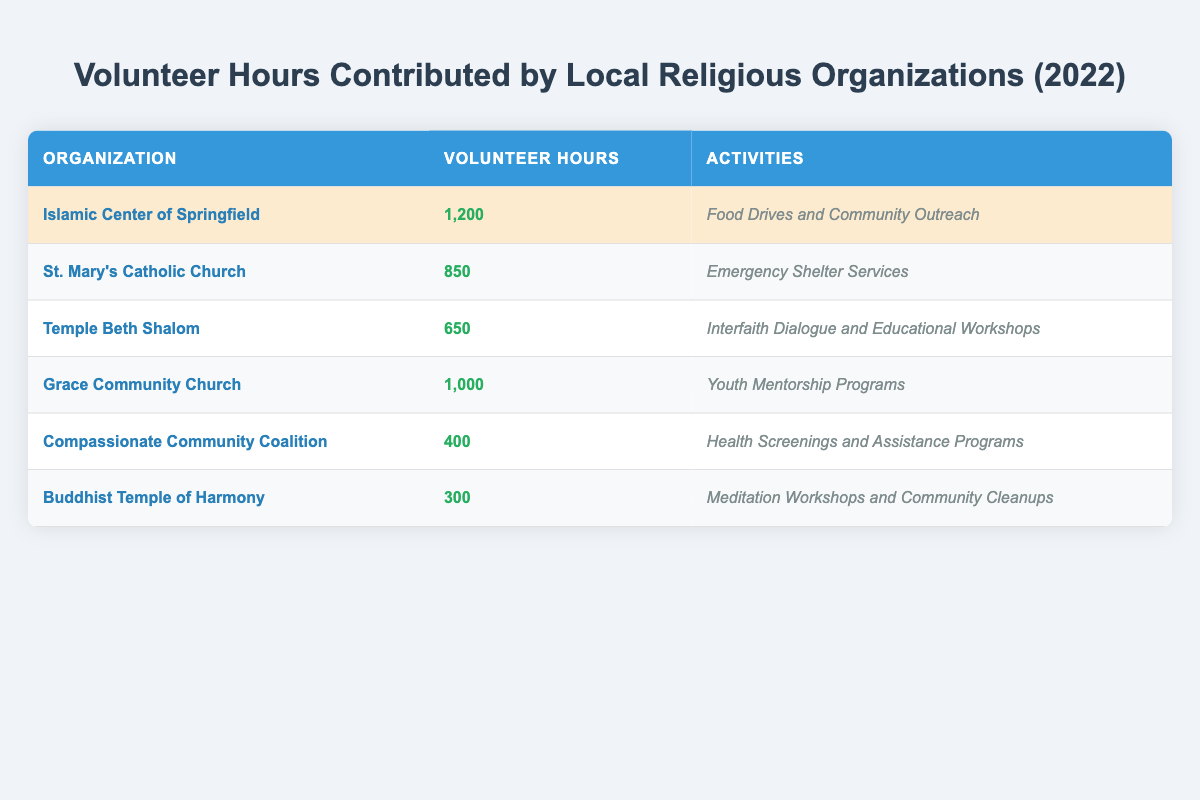What organization contributed the most volunteer hours? The table lists the volunteer hours for each organization, and the Islamic Center of Springfield has the highest number at 1,200 hours.
Answer: Islamic Center of Springfield How many volunteer hours did St. Mary's Catholic Church contribute? According to the table, St. Mary's Catholic Church contributed 850 volunteer hours.
Answer: 850 What activities did the Compassionate Community Coalition focus on? The table shows that the Compassionate Community Coalition focused on health screenings and assistance programs.
Answer: Health Screenings and Assistance Programs What is the total number of volunteer hours contributed by all organizations? By adding the volunteer hours: 1200 + 850 + 650 + 1000 + 400 + 300 = 4350. Therefore, the total is 4350 hours.
Answer: 4350 Which organization contributed fewer than 500 volunteer hours? The table indicates that the Buddhist Temple of Harmony (300 hours) and the Compassionate Community Coalition (400 hours) both contributed fewer than 500 hours.
Answer: Buddhist Temple of Harmony and Compassionate Community Coalition What is the average number of volunteer hours contributed by the organizations listed? There are six organizations. The total volunteer hours are 4350. To find the average, divide 4350 by 6, which equals 725.
Answer: 725 Did the Grace Community Church contribute more volunteer hours than Temple Beth Shalom? Grace Community Church (1000 hours) contributed more than Temple Beth Shalom (650 hours).
Answer: Yes What percentage of the total volunteer hours was contributed by the Islamic Center of Springfield? The Islamic Center of Springfield contributed 1200 hours. To find the percentage: (1200 / 4350) * 100 = 27.59%.
Answer: Approximately 27.59% Which organization contributed the least number of volunteer hours, and what were their activities? The Buddhist Temple of Harmony contributed the least with 300 hours, focusing on meditation workshops and community cleanups.
Answer: Buddhist Temple of Harmony; Meditation Workshops and Community Cleanups Which organization contributed more hours, Grace Community Church or St. Mary's Catholic Church? Grace Community Church contributed 1000 hours, while St. Mary's Catholic Church contributed 850 hours, indicating that Grace Community Church contributed more.
Answer: Grace Community Church 